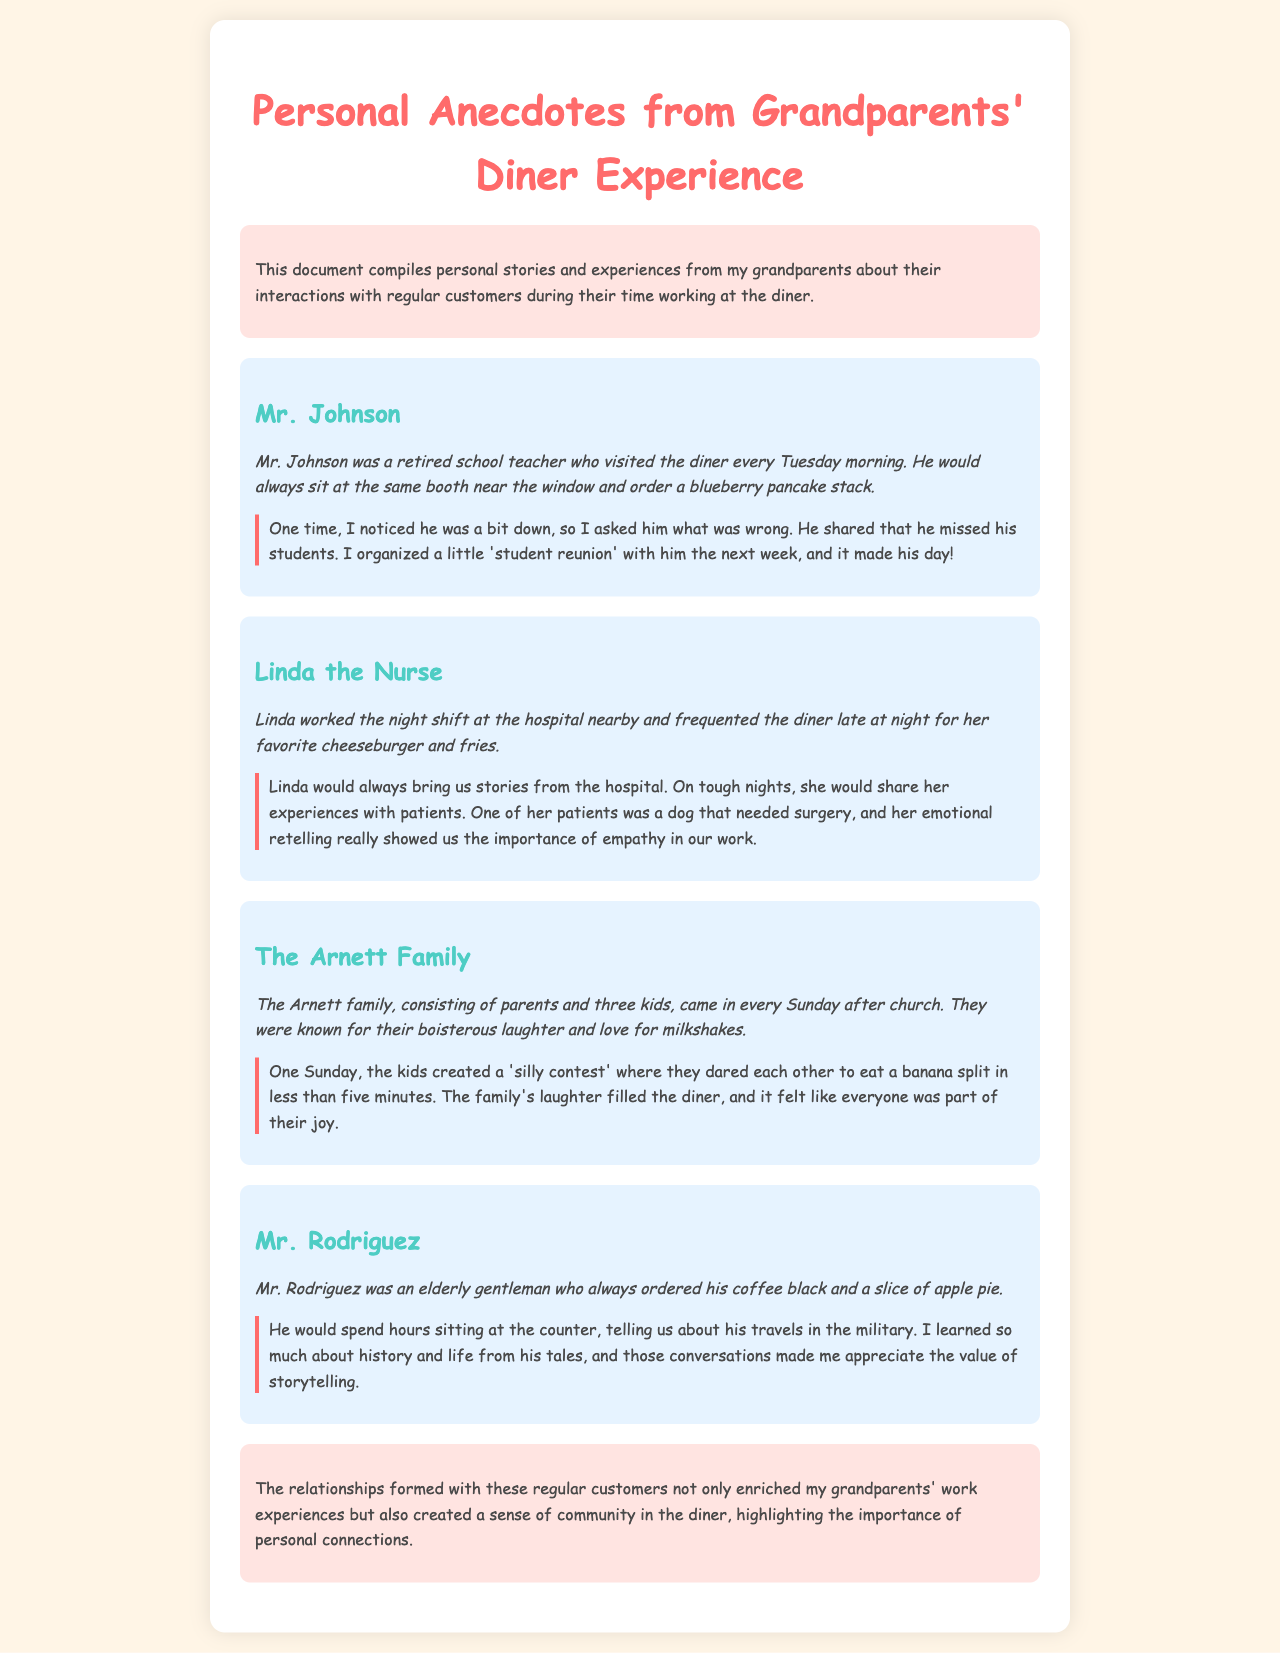what is the name of the retired school teacher? The name of the retired school teacher mentioned is Mr. Johnson.
Answer: Mr. Johnson what did Mr. Johnson always order? Mr. Johnson always ordered a blueberry pancake stack.
Answer: blueberry pancake stack which regular customer worked the night shift at the hospital? The regular customer who worked the night shift at the hospital is Linda.
Answer: Linda what was Linda's favorite diner order? Linda's favorite diner order was a cheeseburger and fries.
Answer: cheeseburger and fries how many kids are in the Arnett family? The Arnett family consists of three kids.
Answer: three kids what did the kids create during their visit? The kids created a 'silly contest' to eat a banana split.
Answer: 'silly contest' what did Mr. Rodriguez always order with his coffee? Mr. Rodriguez always ordered a slice of apple pie with his coffee.
Answer: slice of apple pie what was the emotional storytelling from Linda about? Linda shared her experiences with patients, including a dog that needed surgery.
Answer: a dog that needed surgery how did the customers contribute to the diner's atmosphere? The customers contributed to the diner's atmosphere by forming personal connections and a sense of community.
Answer: personal connections 